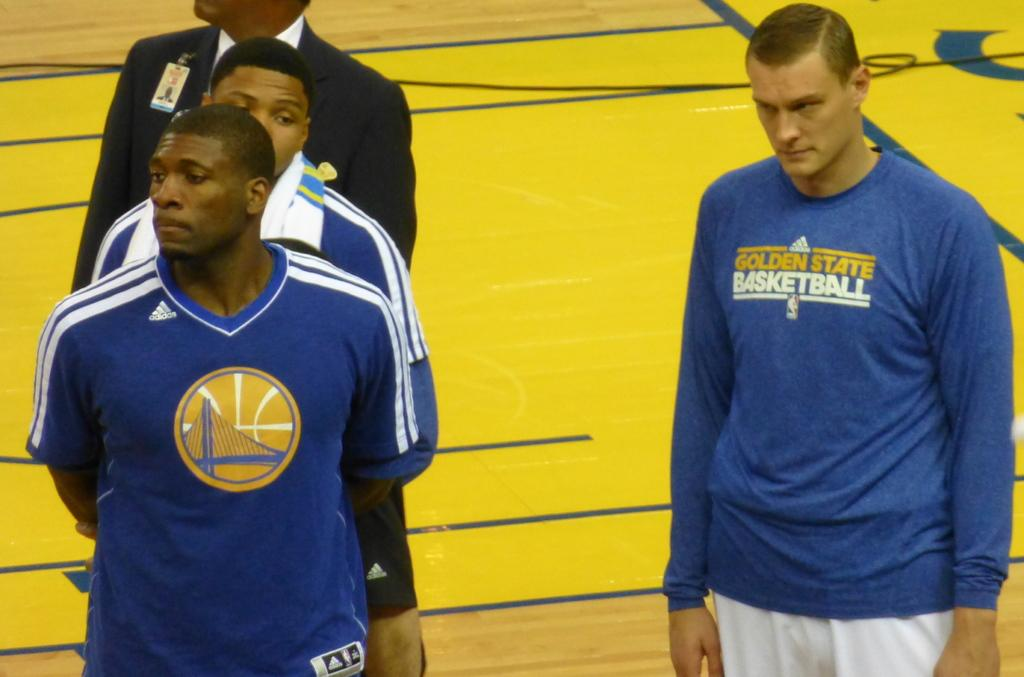Provide a one-sentence caption for the provided image. The three men were associated with Golden State Basketball. 